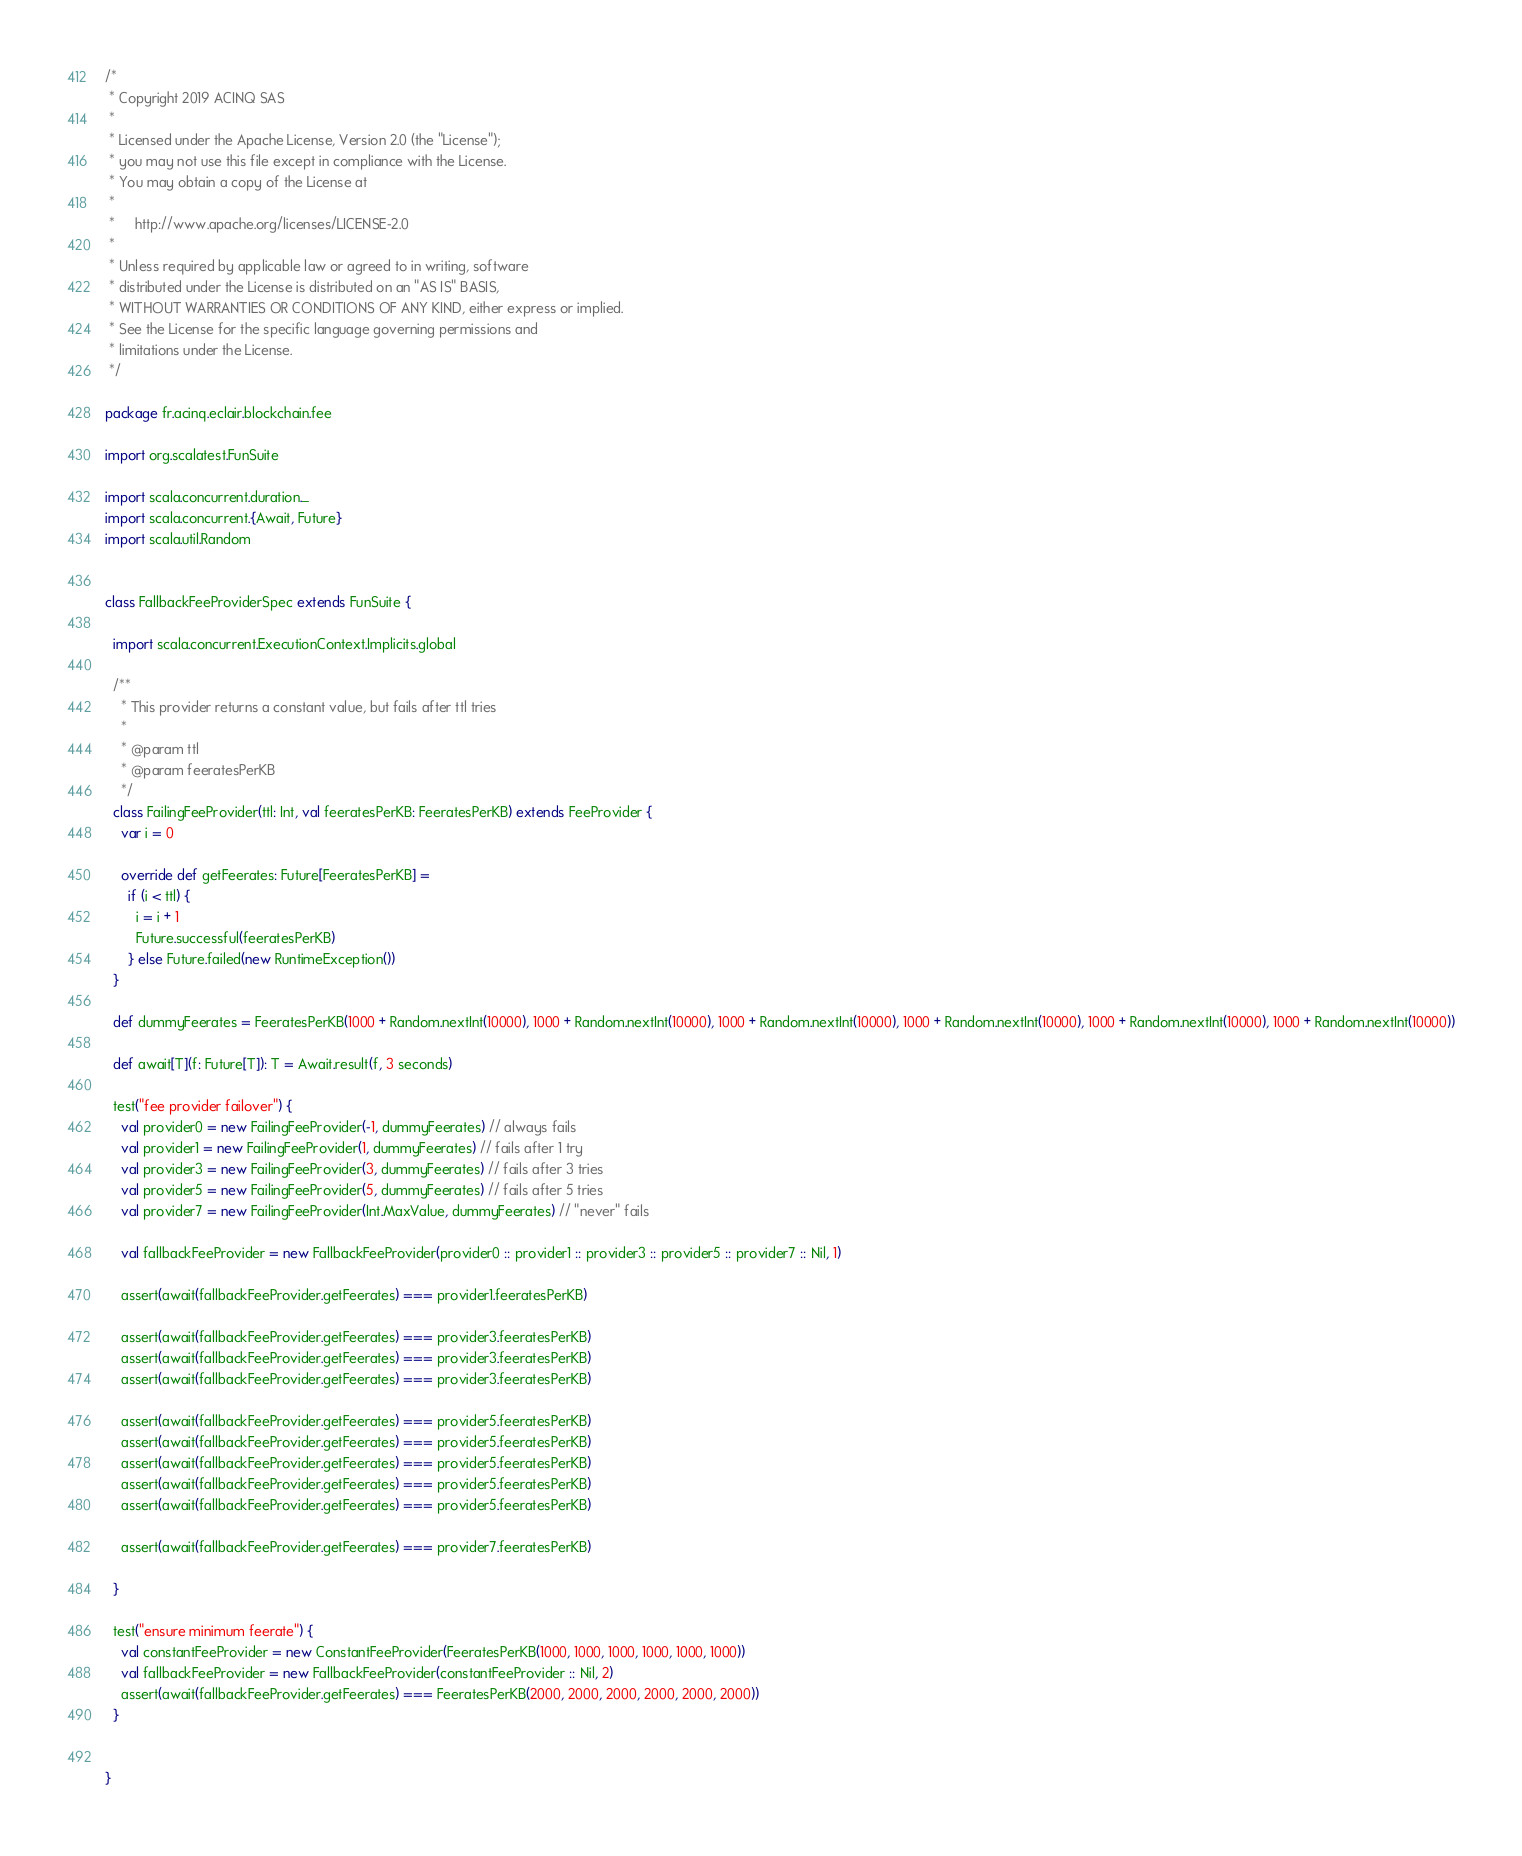<code> <loc_0><loc_0><loc_500><loc_500><_Scala_>/*
 * Copyright 2019 ACINQ SAS
 *
 * Licensed under the Apache License, Version 2.0 (the "License");
 * you may not use this file except in compliance with the License.
 * You may obtain a copy of the License at
 *
 *     http://www.apache.org/licenses/LICENSE-2.0
 *
 * Unless required by applicable law or agreed to in writing, software
 * distributed under the License is distributed on an "AS IS" BASIS,
 * WITHOUT WARRANTIES OR CONDITIONS OF ANY KIND, either express or implied.
 * See the License for the specific language governing permissions and
 * limitations under the License.
 */

package fr.acinq.eclair.blockchain.fee

import org.scalatest.FunSuite

import scala.concurrent.duration._
import scala.concurrent.{Await, Future}
import scala.util.Random


class FallbackFeeProviderSpec extends FunSuite {

  import scala.concurrent.ExecutionContext.Implicits.global

  /**
    * This provider returns a constant value, but fails after ttl tries
    *
    * @param ttl
    * @param feeratesPerKB
    */
  class FailingFeeProvider(ttl: Int, val feeratesPerKB: FeeratesPerKB) extends FeeProvider {
    var i = 0

    override def getFeerates: Future[FeeratesPerKB] =
      if (i < ttl) {
        i = i + 1
        Future.successful(feeratesPerKB)
      } else Future.failed(new RuntimeException())
  }

  def dummyFeerates = FeeratesPerKB(1000 + Random.nextInt(10000), 1000 + Random.nextInt(10000), 1000 + Random.nextInt(10000), 1000 + Random.nextInt(10000), 1000 + Random.nextInt(10000), 1000 + Random.nextInt(10000))

  def await[T](f: Future[T]): T = Await.result(f, 3 seconds)

  test("fee provider failover") {
    val provider0 = new FailingFeeProvider(-1, dummyFeerates) // always fails
    val provider1 = new FailingFeeProvider(1, dummyFeerates) // fails after 1 try
    val provider3 = new FailingFeeProvider(3, dummyFeerates) // fails after 3 tries
    val provider5 = new FailingFeeProvider(5, dummyFeerates) // fails after 5 tries
    val provider7 = new FailingFeeProvider(Int.MaxValue, dummyFeerates) // "never" fails

    val fallbackFeeProvider = new FallbackFeeProvider(provider0 :: provider1 :: provider3 :: provider5 :: provider7 :: Nil, 1)

    assert(await(fallbackFeeProvider.getFeerates) === provider1.feeratesPerKB)

    assert(await(fallbackFeeProvider.getFeerates) === provider3.feeratesPerKB)
    assert(await(fallbackFeeProvider.getFeerates) === provider3.feeratesPerKB)
    assert(await(fallbackFeeProvider.getFeerates) === provider3.feeratesPerKB)

    assert(await(fallbackFeeProvider.getFeerates) === provider5.feeratesPerKB)
    assert(await(fallbackFeeProvider.getFeerates) === provider5.feeratesPerKB)
    assert(await(fallbackFeeProvider.getFeerates) === provider5.feeratesPerKB)
    assert(await(fallbackFeeProvider.getFeerates) === provider5.feeratesPerKB)
    assert(await(fallbackFeeProvider.getFeerates) === provider5.feeratesPerKB)

    assert(await(fallbackFeeProvider.getFeerates) === provider7.feeratesPerKB)

  }

  test("ensure minimum feerate") {
    val constantFeeProvider = new ConstantFeeProvider(FeeratesPerKB(1000, 1000, 1000, 1000, 1000, 1000))
    val fallbackFeeProvider = new FallbackFeeProvider(constantFeeProvider :: Nil, 2)
    assert(await(fallbackFeeProvider.getFeerates) === FeeratesPerKB(2000, 2000, 2000, 2000, 2000, 2000))
  }


}
</code> 